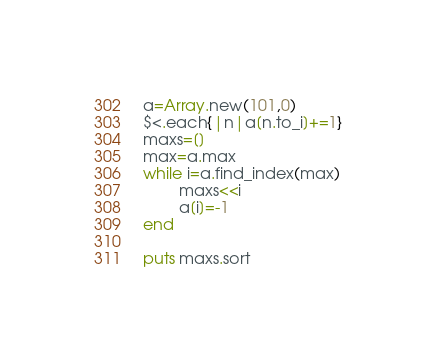Convert code to text. <code><loc_0><loc_0><loc_500><loc_500><_Ruby_>a=Array.new(101,0)
$<.each{|n|a[n.to_i]+=1}
maxs=[]
max=a.max
while i=a.find_index(max)
        maxs<<i
        a[i]=-1
end

puts maxs.sort</code> 